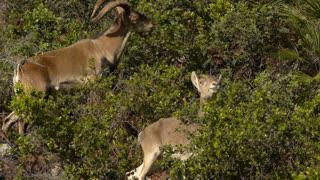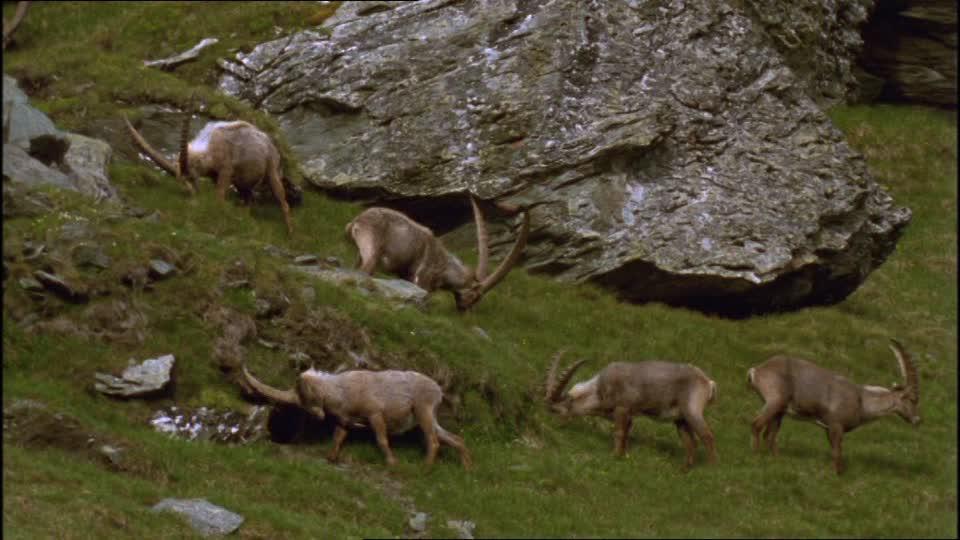The first image is the image on the left, the second image is the image on the right. For the images displayed, is the sentence "There is a single horned animal in each of the images." factually correct? Answer yes or no. No. The first image is the image on the left, the second image is the image on the right. Given the left and right images, does the statement "An image shows one right-facing horned animal with moulting coat, standing in a green grassy area." hold true? Answer yes or no. No. 